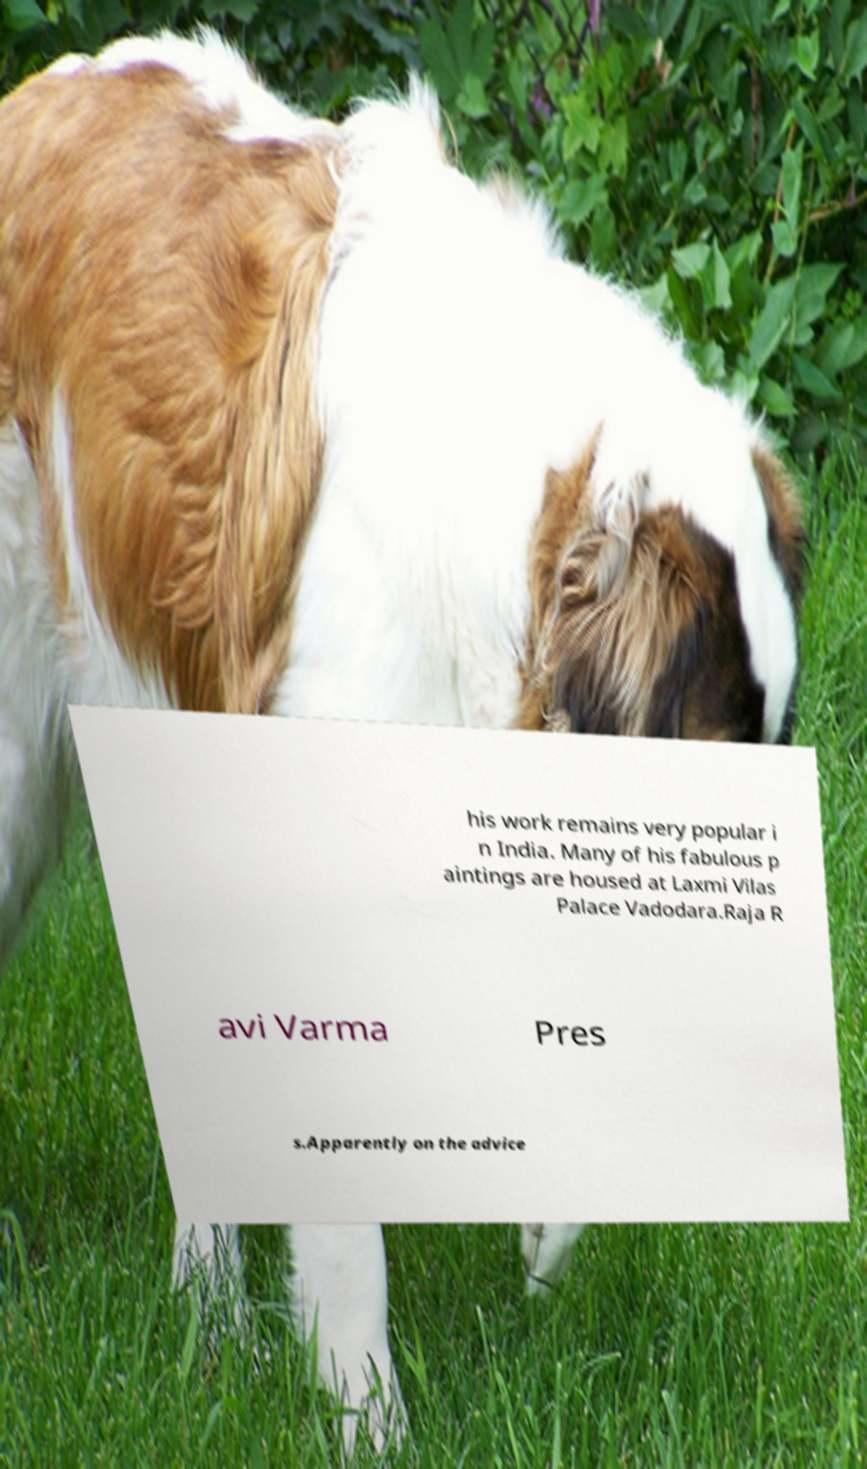For documentation purposes, I need the text within this image transcribed. Could you provide that? his work remains very popular i n India. Many of his fabulous p aintings are housed at Laxmi Vilas Palace Vadodara.Raja R avi Varma Pres s.Apparently on the advice 